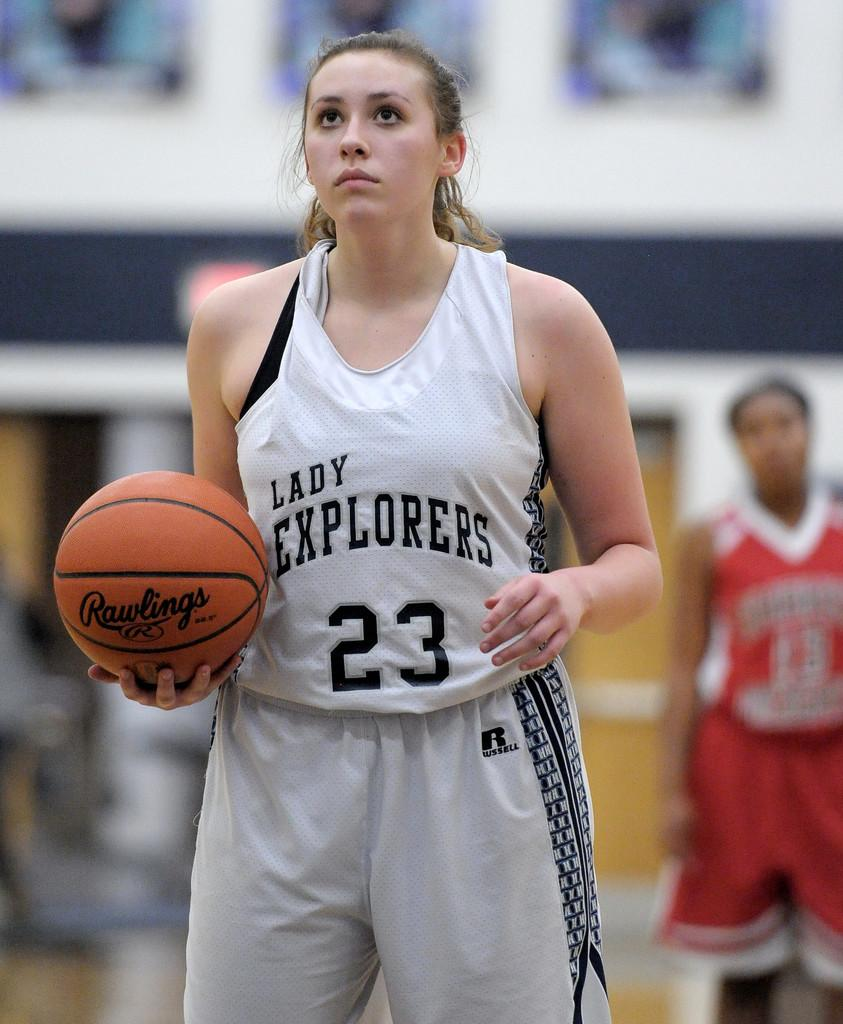<image>
Write a terse but informative summary of the picture. lady explorers player number 23 holding rawlings basketball 